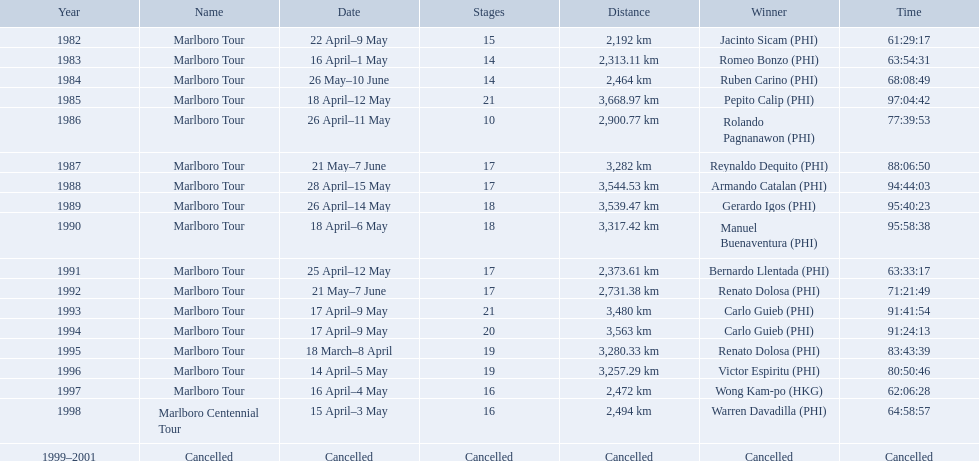What were the tour names during le tour de filipinas? Marlboro Tour, Marlboro Tour, Marlboro Tour, Marlboro Tour, Marlboro Tour, Marlboro Tour, Marlboro Tour, Marlboro Tour, Marlboro Tour, Marlboro Tour, Marlboro Tour, Marlboro Tour, Marlboro Tour, Marlboro Tour, Marlboro Tour, Marlboro Tour, Marlboro Centennial Tour, Cancelled. What were the recorded distances for each marlboro tour? 2,192 km, 2,313.11 km, 2,464 km, 3,668.97 km, 2,900.77 km, 3,282 km, 3,544.53 km, 3,539.47 km, 3,317.42 km, 2,373.61 km, 2,731.38 km, 3,480 km, 3,563 km, 3,280.33 km, 3,257.29 km, 2,472 km. And of those distances, which was the longest? 3,668.97 km. How far did the marlboro tour travel each year? 2,192 km, 2,313.11 km, 2,464 km, 3,668.97 km, 2,900.77 km, 3,282 km, 3,544.53 km, 3,539.47 km, 3,317.42 km, 2,373.61 km, 2,731.38 km, 3,480 km, 3,563 km, 3,280.33 km, 3,257.29 km, 2,472 km, 2,494 km, Cancelled. In what year did they travel the furthest? 1985. How far did they travel that year? 3,668.97 km. Which year did warren davdilla (w.d.) appear? 1998. What tour did w.d. complete? Marlboro Centennial Tour. What is the time recorded in the same row as w.d.? 64:58:57. What are the spans traveled on the trip? 2,192 km, 2,313.11 km, 2,464 km, 3,668.97 km, 2,900.77 km, 3,282 km, 3,544.53 km, 3,539.47 km, 3,317.42 km, 2,373.61 km, 2,731.38 km, 3,480 km, 3,563 km, 3,280.33 km, 3,257.29 km, 2,472 km, 2,494 km. Which of these are the biggest? 3,668.97 km. Who were all the victors? Jacinto Sicam (PHI), Romeo Bonzo (PHI), Ruben Carino (PHI), Pepito Calip (PHI), Rolando Pagnanawon (PHI), Reynaldo Dequito (PHI), Armando Catalan (PHI), Gerardo Igos (PHI), Manuel Buenaventura (PHI), Bernardo Llentada (PHI), Renato Dolosa (PHI), Carlo Guieb (PHI), Carlo Guieb (PHI), Renato Dolosa (PHI), Victor Espiritu (PHI), Wong Kam-po (HKG), Warren Davadilla (PHI), Cancelled. When did they participate? 1982, 1983, 1984, 1985, 1986, 1987, 1988, 1989, 1990, 1991, 1992, 1993, 1994, 1995, 1996, 1997, 1998, 1999–2001. What were their completion times? 61:29:17, 63:54:31, 68:08:49, 97:04:42, 77:39:53, 88:06:50, 94:44:03, 95:40:23, 95:58:38, 63:33:17, 71:21:49, 91:41:54, 91:24:13, 83:43:39, 80:50:46, 62:06:28, 64:58:57, Cancelled. And who was triumphant in 1998? Warren Davadilla (PHI). What was his duration? 64:58:57. In 1998, which race did warren davadilla participate in? Marlboro Centennial Tour. What was davadilla's completion time for the marlboro centennial tour? 64:58:57. 